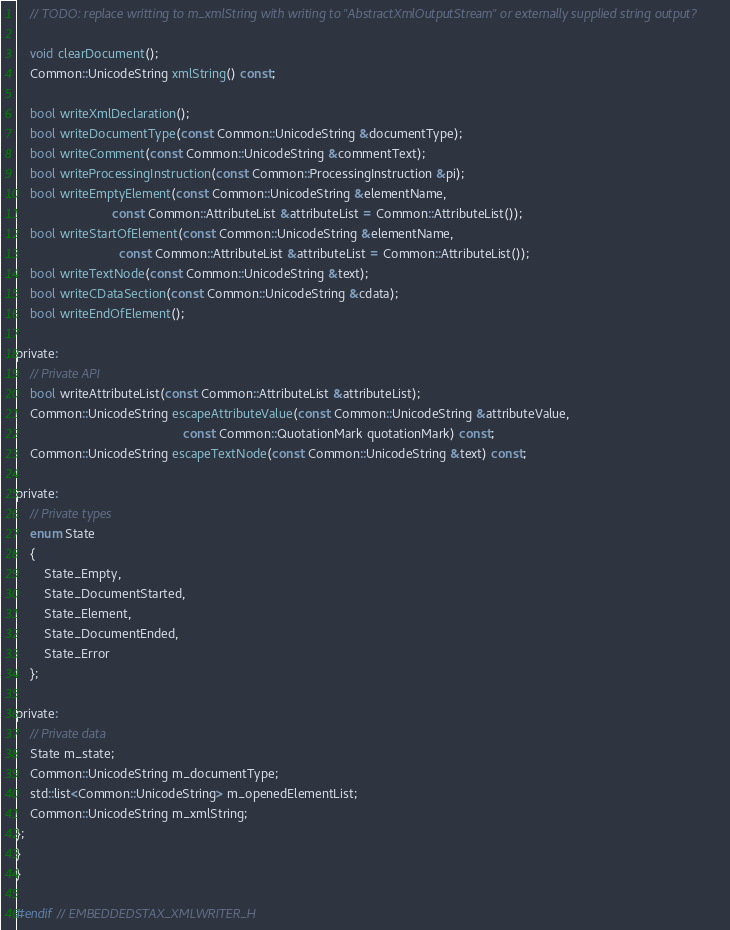<code> <loc_0><loc_0><loc_500><loc_500><_C_>    // TODO: replace writting to m_xmlString with writing to "AbstractXmlOutputStream" or externally supplied string output?

    void clearDocument();
    Common::UnicodeString xmlString() const;

    bool writeXmlDeclaration();
    bool writeDocumentType(const Common::UnicodeString &documentType);
    bool writeComment(const Common::UnicodeString &commentText);
    bool writeProcessingInstruction(const Common::ProcessingInstruction &pi);
    bool writeEmptyElement(const Common::UnicodeString &elementName,
                           const Common::AttributeList &attributeList = Common::AttributeList());
    bool writeStartOfElement(const Common::UnicodeString &elementName,
                             const Common::AttributeList &attributeList = Common::AttributeList());
    bool writeTextNode(const Common::UnicodeString &text);
    bool writeCDataSection(const Common::UnicodeString &cdata);
    bool writeEndOfElement();

private:
    // Private API
    bool writeAttributeList(const Common::AttributeList &attributeList);
    Common::UnicodeString escapeAttributeValue(const Common::UnicodeString &attributeValue,
                                               const Common::QuotationMark quotationMark) const;
    Common::UnicodeString escapeTextNode(const Common::UnicodeString &text) const;

private:
    // Private types
    enum State
    {
        State_Empty,
        State_DocumentStarted,
        State_Element,
        State_DocumentEnded,
        State_Error
    };

private:
    // Private data
    State m_state;
    Common::UnicodeString m_documentType;
    std::list<Common::UnicodeString> m_openedElementList;
    Common::UnicodeString m_xmlString;
};
}
}

#endif // EMBEDDEDSTAX_XMLWRITER_H
</code> 